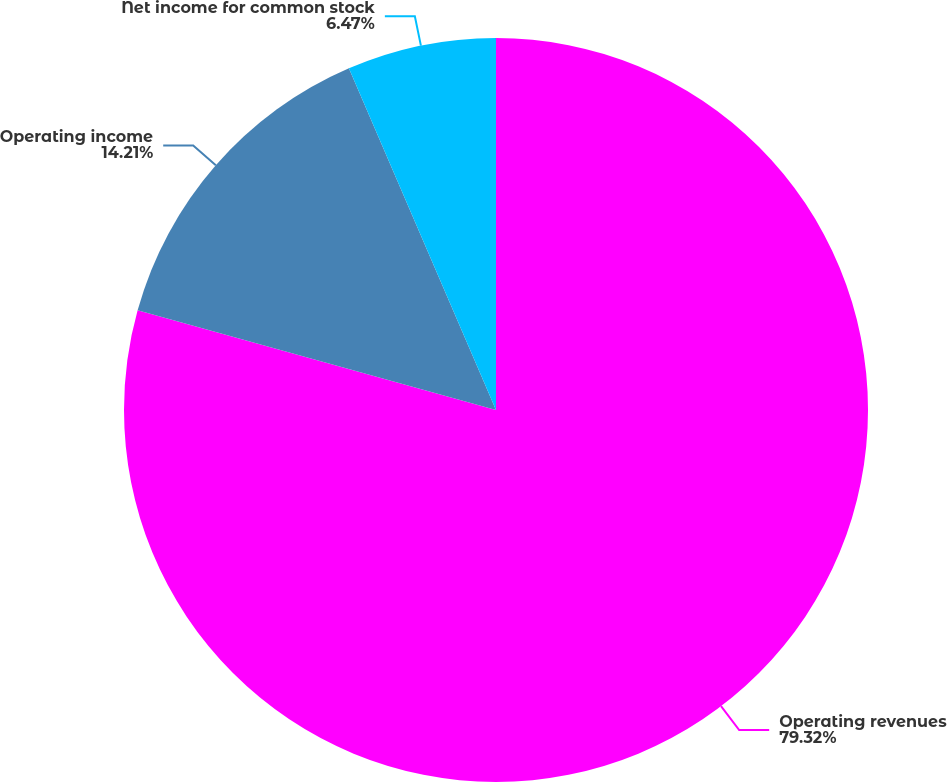Convert chart to OTSL. <chart><loc_0><loc_0><loc_500><loc_500><pie_chart><fcel>Operating revenues<fcel>Operating income<fcel>Net income for common stock<nl><fcel>79.32%<fcel>14.21%<fcel>6.47%<nl></chart> 